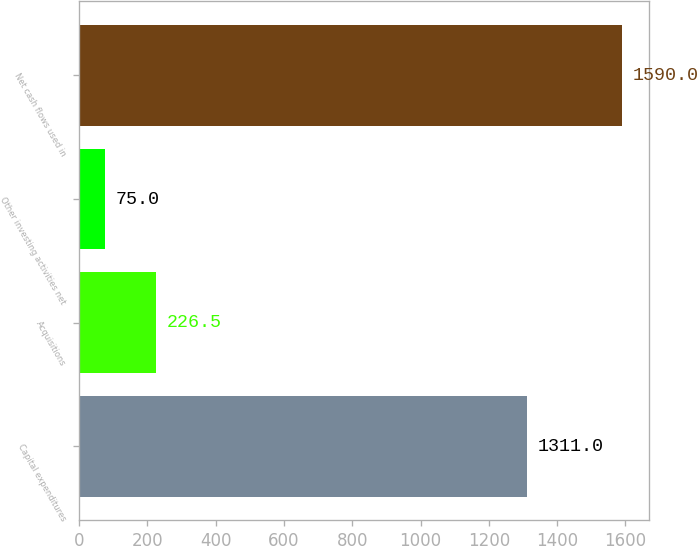Convert chart to OTSL. <chart><loc_0><loc_0><loc_500><loc_500><bar_chart><fcel>Capital expenditures<fcel>Acquisitions<fcel>Other investing activities net<fcel>Net cash flows used in<nl><fcel>1311<fcel>226.5<fcel>75<fcel>1590<nl></chart> 